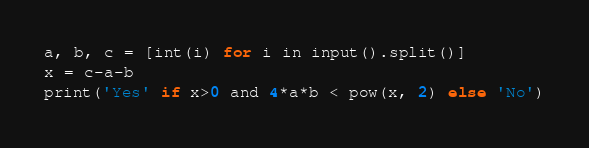Convert code to text. <code><loc_0><loc_0><loc_500><loc_500><_Python_>a, b, c = [int(i) for i in input().split()]
x = c-a-b
print('Yes' if x>0 and 4*a*b < pow(x, 2) else 'No')</code> 